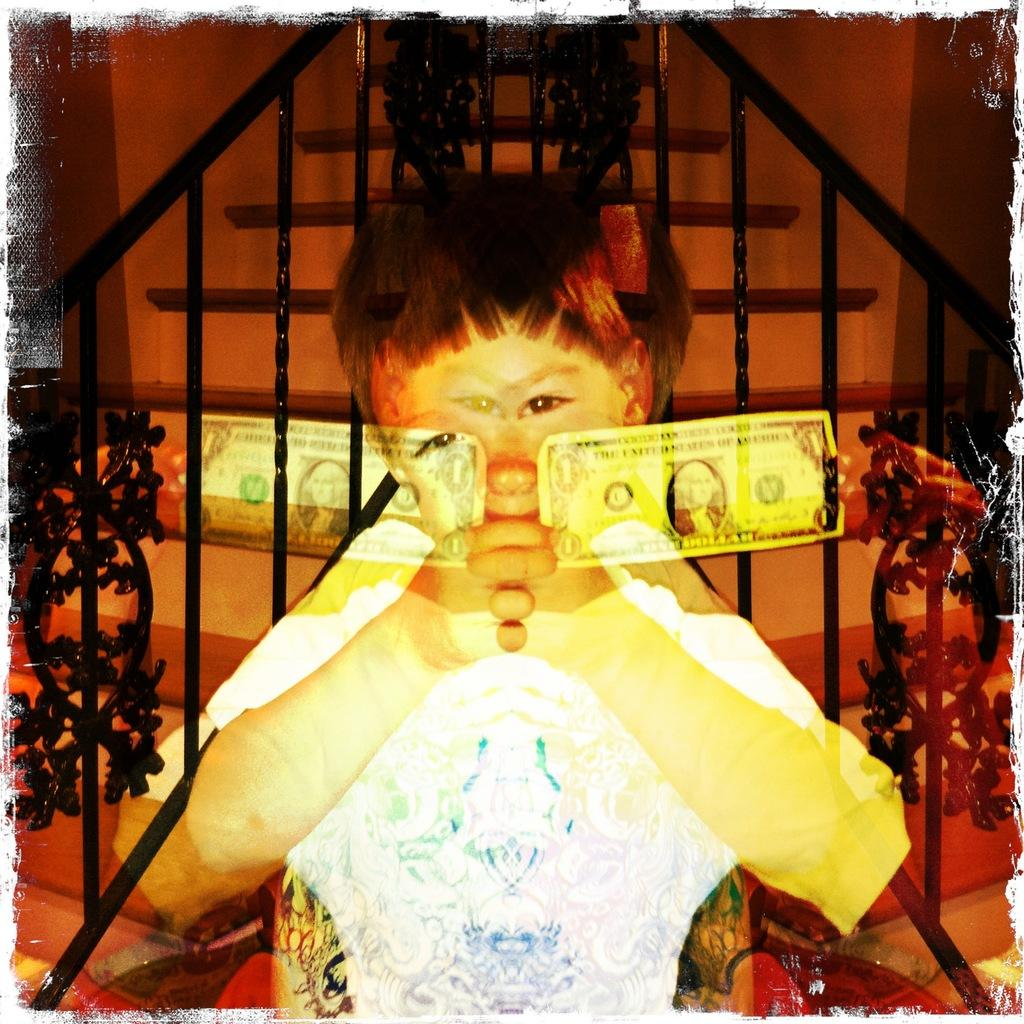What is the main subject of the picture? The main subject of the picture is an image of a boy. What architectural feature can be seen in the image? There is a staircase visible in the image. What objects are present in the image that resemble long, thin bars? There are rods in the image. What type of barrier is visible in the middle of the image? There is a fence visible in the middle of the image. What structure is located at the top of the image? There is a wall at the top of the image. What type of bread can be seen in the jar on the wall in the image? There is no bread or jar present in the image; the wall is solid. Is the coat hanging on the fence in the image? There is no coat visible in the image; only the fence and rods are present. 